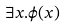<formula> <loc_0><loc_0><loc_500><loc_500>\exists x . \phi ( x )</formula> 